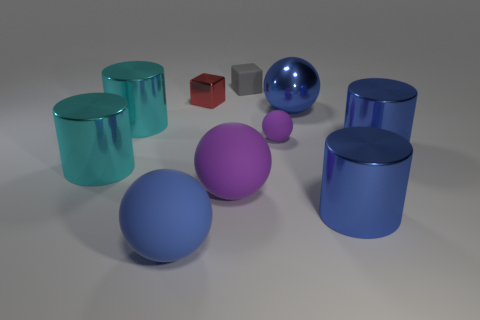Subtract all metal balls. How many balls are left? 3 Subtract all gray cubes. How many cubes are left? 1 Subtract all blocks. How many objects are left? 8 Subtract 2 cylinders. How many cylinders are left? 2 Subtract all red cylinders. How many purple balls are left? 2 Subtract all large yellow metal things. Subtract all blue metal spheres. How many objects are left? 9 Add 2 tiny gray cubes. How many tiny gray cubes are left? 3 Add 5 big cyan matte blocks. How many big cyan matte blocks exist? 5 Subtract 0 brown cylinders. How many objects are left? 10 Subtract all brown cylinders. Subtract all cyan balls. How many cylinders are left? 4 